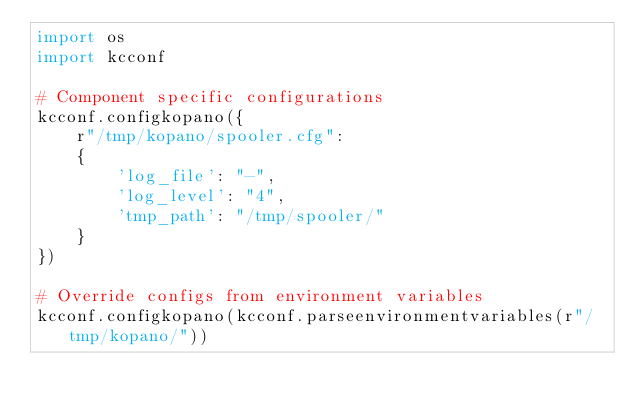<code> <loc_0><loc_0><loc_500><loc_500><_Python_>import os
import kcconf

# Component specific configurations
kcconf.configkopano({
    r"/tmp/kopano/spooler.cfg":
    {
        'log_file': "-",
        'log_level': "4",
        'tmp_path': "/tmp/spooler/"
    }
})

# Override configs from environment variables
kcconf.configkopano(kcconf.parseenvironmentvariables(r"/tmp/kopano/"))
</code> 